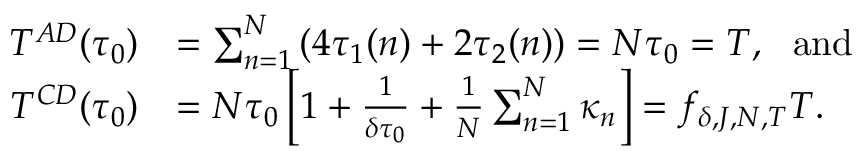Convert formula to latex. <formula><loc_0><loc_0><loc_500><loc_500>\begin{array} { r l } { T ^ { A D } ( \tau _ { 0 } ) } & { = \sum _ { n = 1 } ^ { N } \left ( 4 \tau _ { 1 } ( n ) + 2 \tau _ { 2 } ( n ) \right ) = N \tau _ { 0 } = T , a n d } \\ { T ^ { C D } ( \tau _ { 0 } ) } & { = N \tau _ { 0 } \left [ 1 + \frac { 1 } { \delta \tau _ { 0 } } + \frac { 1 } { N } \sum _ { n = 1 } ^ { N } \kappa _ { n } \right ] = f _ { \delta , J , N , T } T . } \end{array}</formula> 